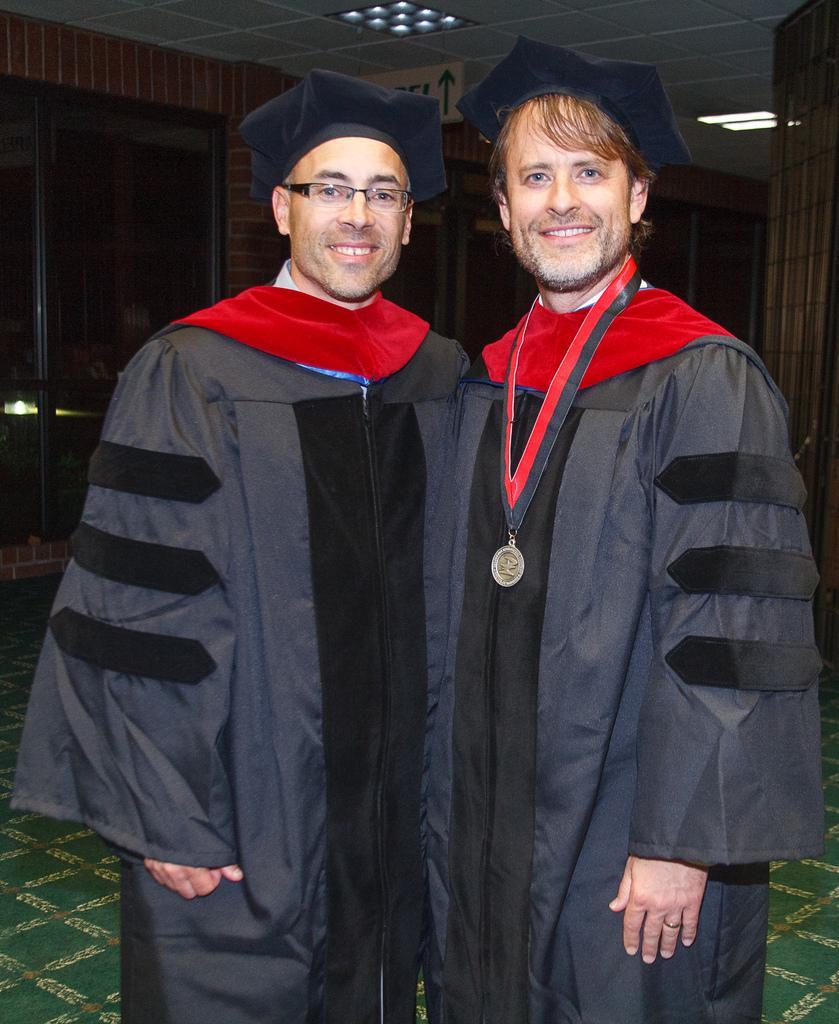Could you give a brief overview of what you see in this image? In this picture we can see two people, they are wearing caps, one person is wearing a medal and in the background we can see a roof, wall, glass doors, lights and some objects. 